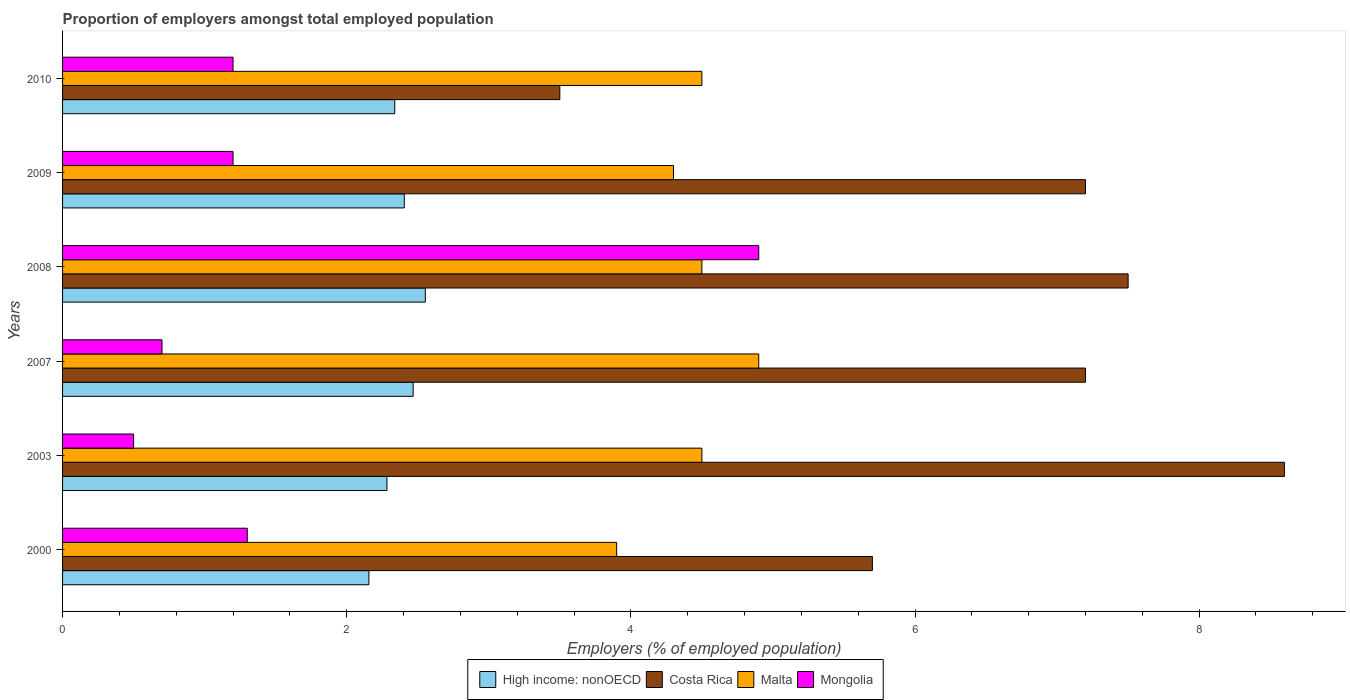How many bars are there on the 6th tick from the bottom?
Keep it short and to the point. 4. Across all years, what is the maximum proportion of employers in High income: nonOECD?
Give a very brief answer. 2.55. In which year was the proportion of employers in High income: nonOECD maximum?
Keep it short and to the point. 2008. In which year was the proportion of employers in High income: nonOECD minimum?
Your response must be concise. 2000. What is the total proportion of employers in High income: nonOECD in the graph?
Give a very brief answer. 14.2. What is the difference between the proportion of employers in Mongolia in 2010 and the proportion of employers in Malta in 2003?
Your response must be concise. -3.3. What is the average proportion of employers in Costa Rica per year?
Offer a very short reply. 6.62. In the year 2010, what is the difference between the proportion of employers in Mongolia and proportion of employers in Malta?
Provide a short and direct response. -3.3. In how many years, is the proportion of employers in High income: nonOECD greater than 5.2 %?
Provide a succinct answer. 0. What is the ratio of the proportion of employers in Costa Rica in 2003 to that in 2008?
Your answer should be compact. 1.15. Is the difference between the proportion of employers in Mongolia in 2003 and 2007 greater than the difference between the proportion of employers in Malta in 2003 and 2007?
Your response must be concise. Yes. What is the difference between the highest and the second highest proportion of employers in Costa Rica?
Provide a short and direct response. 1.1. What is the difference between the highest and the lowest proportion of employers in Malta?
Provide a short and direct response. 1. In how many years, is the proportion of employers in High income: nonOECD greater than the average proportion of employers in High income: nonOECD taken over all years?
Provide a succinct answer. 3. Is the sum of the proportion of employers in Costa Rica in 2000 and 2007 greater than the maximum proportion of employers in High income: nonOECD across all years?
Keep it short and to the point. Yes. Is it the case that in every year, the sum of the proportion of employers in Malta and proportion of employers in Costa Rica is greater than the sum of proportion of employers in High income: nonOECD and proportion of employers in Mongolia?
Offer a terse response. No. What does the 4th bar from the top in 2007 represents?
Provide a short and direct response. High income: nonOECD. What does the 2nd bar from the bottom in 2010 represents?
Offer a terse response. Costa Rica. How many legend labels are there?
Give a very brief answer. 4. What is the title of the graph?
Offer a very short reply. Proportion of employers amongst total employed population. What is the label or title of the X-axis?
Your response must be concise. Employers (% of employed population). What is the Employers (% of employed population) of High income: nonOECD in 2000?
Make the answer very short. 2.16. What is the Employers (% of employed population) in Costa Rica in 2000?
Your response must be concise. 5.7. What is the Employers (% of employed population) in Malta in 2000?
Ensure brevity in your answer.  3.9. What is the Employers (% of employed population) in Mongolia in 2000?
Offer a terse response. 1.3. What is the Employers (% of employed population) of High income: nonOECD in 2003?
Provide a succinct answer. 2.28. What is the Employers (% of employed population) in Costa Rica in 2003?
Make the answer very short. 8.6. What is the Employers (% of employed population) of High income: nonOECD in 2007?
Offer a very short reply. 2.47. What is the Employers (% of employed population) of Costa Rica in 2007?
Offer a terse response. 7.2. What is the Employers (% of employed population) in Malta in 2007?
Provide a short and direct response. 4.9. What is the Employers (% of employed population) in Mongolia in 2007?
Offer a very short reply. 0.7. What is the Employers (% of employed population) in High income: nonOECD in 2008?
Ensure brevity in your answer.  2.55. What is the Employers (% of employed population) of Malta in 2008?
Provide a succinct answer. 4.5. What is the Employers (% of employed population) of Mongolia in 2008?
Your response must be concise. 4.9. What is the Employers (% of employed population) in High income: nonOECD in 2009?
Offer a terse response. 2.41. What is the Employers (% of employed population) in Costa Rica in 2009?
Offer a terse response. 7.2. What is the Employers (% of employed population) of Malta in 2009?
Provide a short and direct response. 4.3. What is the Employers (% of employed population) in Mongolia in 2009?
Give a very brief answer. 1.2. What is the Employers (% of employed population) of High income: nonOECD in 2010?
Provide a succinct answer. 2.34. What is the Employers (% of employed population) in Costa Rica in 2010?
Offer a terse response. 3.5. What is the Employers (% of employed population) of Mongolia in 2010?
Ensure brevity in your answer.  1.2. Across all years, what is the maximum Employers (% of employed population) in High income: nonOECD?
Provide a succinct answer. 2.55. Across all years, what is the maximum Employers (% of employed population) of Costa Rica?
Provide a short and direct response. 8.6. Across all years, what is the maximum Employers (% of employed population) of Malta?
Ensure brevity in your answer.  4.9. Across all years, what is the maximum Employers (% of employed population) of Mongolia?
Your answer should be very brief. 4.9. Across all years, what is the minimum Employers (% of employed population) of High income: nonOECD?
Offer a very short reply. 2.16. Across all years, what is the minimum Employers (% of employed population) of Malta?
Give a very brief answer. 3.9. What is the total Employers (% of employed population) of High income: nonOECD in the graph?
Offer a terse response. 14.2. What is the total Employers (% of employed population) in Costa Rica in the graph?
Keep it short and to the point. 39.7. What is the total Employers (% of employed population) of Malta in the graph?
Give a very brief answer. 26.6. What is the total Employers (% of employed population) in Mongolia in the graph?
Keep it short and to the point. 9.8. What is the difference between the Employers (% of employed population) of High income: nonOECD in 2000 and that in 2003?
Make the answer very short. -0.13. What is the difference between the Employers (% of employed population) of High income: nonOECD in 2000 and that in 2007?
Provide a succinct answer. -0.31. What is the difference between the Employers (% of employed population) in Costa Rica in 2000 and that in 2007?
Offer a very short reply. -1.5. What is the difference between the Employers (% of employed population) in Mongolia in 2000 and that in 2007?
Provide a short and direct response. 0.6. What is the difference between the Employers (% of employed population) of High income: nonOECD in 2000 and that in 2008?
Provide a succinct answer. -0.4. What is the difference between the Employers (% of employed population) in Malta in 2000 and that in 2008?
Offer a very short reply. -0.6. What is the difference between the Employers (% of employed population) in High income: nonOECD in 2000 and that in 2009?
Keep it short and to the point. -0.25. What is the difference between the Employers (% of employed population) of Malta in 2000 and that in 2009?
Provide a short and direct response. -0.4. What is the difference between the Employers (% of employed population) in High income: nonOECD in 2000 and that in 2010?
Give a very brief answer. -0.18. What is the difference between the Employers (% of employed population) of Costa Rica in 2000 and that in 2010?
Offer a terse response. 2.2. What is the difference between the Employers (% of employed population) of Malta in 2000 and that in 2010?
Your answer should be compact. -0.6. What is the difference between the Employers (% of employed population) of High income: nonOECD in 2003 and that in 2007?
Your response must be concise. -0.18. What is the difference between the Employers (% of employed population) of Costa Rica in 2003 and that in 2007?
Ensure brevity in your answer.  1.4. What is the difference between the Employers (% of employed population) of Malta in 2003 and that in 2007?
Your answer should be compact. -0.4. What is the difference between the Employers (% of employed population) in High income: nonOECD in 2003 and that in 2008?
Give a very brief answer. -0.27. What is the difference between the Employers (% of employed population) in Costa Rica in 2003 and that in 2008?
Offer a terse response. 1.1. What is the difference between the Employers (% of employed population) of Malta in 2003 and that in 2008?
Your response must be concise. 0. What is the difference between the Employers (% of employed population) of High income: nonOECD in 2003 and that in 2009?
Offer a terse response. -0.12. What is the difference between the Employers (% of employed population) in High income: nonOECD in 2003 and that in 2010?
Your response must be concise. -0.06. What is the difference between the Employers (% of employed population) of Costa Rica in 2003 and that in 2010?
Give a very brief answer. 5.1. What is the difference between the Employers (% of employed population) of Mongolia in 2003 and that in 2010?
Provide a succinct answer. -0.7. What is the difference between the Employers (% of employed population) in High income: nonOECD in 2007 and that in 2008?
Make the answer very short. -0.09. What is the difference between the Employers (% of employed population) of Costa Rica in 2007 and that in 2008?
Your answer should be very brief. -0.3. What is the difference between the Employers (% of employed population) in High income: nonOECD in 2007 and that in 2009?
Your answer should be compact. 0.06. What is the difference between the Employers (% of employed population) in Malta in 2007 and that in 2009?
Offer a very short reply. 0.6. What is the difference between the Employers (% of employed population) of Mongolia in 2007 and that in 2009?
Your answer should be compact. -0.5. What is the difference between the Employers (% of employed population) in High income: nonOECD in 2007 and that in 2010?
Your response must be concise. 0.13. What is the difference between the Employers (% of employed population) of High income: nonOECD in 2008 and that in 2009?
Provide a short and direct response. 0.15. What is the difference between the Employers (% of employed population) of High income: nonOECD in 2008 and that in 2010?
Make the answer very short. 0.21. What is the difference between the Employers (% of employed population) in Malta in 2008 and that in 2010?
Provide a short and direct response. 0. What is the difference between the Employers (% of employed population) of Mongolia in 2008 and that in 2010?
Keep it short and to the point. 3.7. What is the difference between the Employers (% of employed population) in High income: nonOECD in 2009 and that in 2010?
Provide a short and direct response. 0.07. What is the difference between the Employers (% of employed population) of Malta in 2009 and that in 2010?
Make the answer very short. -0.2. What is the difference between the Employers (% of employed population) in High income: nonOECD in 2000 and the Employers (% of employed population) in Costa Rica in 2003?
Keep it short and to the point. -6.44. What is the difference between the Employers (% of employed population) in High income: nonOECD in 2000 and the Employers (% of employed population) in Malta in 2003?
Offer a terse response. -2.34. What is the difference between the Employers (% of employed population) in High income: nonOECD in 2000 and the Employers (% of employed population) in Mongolia in 2003?
Keep it short and to the point. 1.66. What is the difference between the Employers (% of employed population) of Malta in 2000 and the Employers (% of employed population) of Mongolia in 2003?
Your answer should be very brief. 3.4. What is the difference between the Employers (% of employed population) in High income: nonOECD in 2000 and the Employers (% of employed population) in Costa Rica in 2007?
Your answer should be very brief. -5.04. What is the difference between the Employers (% of employed population) of High income: nonOECD in 2000 and the Employers (% of employed population) of Malta in 2007?
Offer a terse response. -2.74. What is the difference between the Employers (% of employed population) of High income: nonOECD in 2000 and the Employers (% of employed population) of Mongolia in 2007?
Provide a succinct answer. 1.46. What is the difference between the Employers (% of employed population) of Costa Rica in 2000 and the Employers (% of employed population) of Mongolia in 2007?
Provide a short and direct response. 5. What is the difference between the Employers (% of employed population) of Malta in 2000 and the Employers (% of employed population) of Mongolia in 2007?
Give a very brief answer. 3.2. What is the difference between the Employers (% of employed population) of High income: nonOECD in 2000 and the Employers (% of employed population) of Costa Rica in 2008?
Make the answer very short. -5.34. What is the difference between the Employers (% of employed population) in High income: nonOECD in 2000 and the Employers (% of employed population) in Malta in 2008?
Keep it short and to the point. -2.34. What is the difference between the Employers (% of employed population) of High income: nonOECD in 2000 and the Employers (% of employed population) of Mongolia in 2008?
Ensure brevity in your answer.  -2.74. What is the difference between the Employers (% of employed population) of Costa Rica in 2000 and the Employers (% of employed population) of Malta in 2008?
Offer a very short reply. 1.2. What is the difference between the Employers (% of employed population) of Costa Rica in 2000 and the Employers (% of employed population) of Mongolia in 2008?
Keep it short and to the point. 0.8. What is the difference between the Employers (% of employed population) in Malta in 2000 and the Employers (% of employed population) in Mongolia in 2008?
Provide a succinct answer. -1. What is the difference between the Employers (% of employed population) of High income: nonOECD in 2000 and the Employers (% of employed population) of Costa Rica in 2009?
Your answer should be compact. -5.04. What is the difference between the Employers (% of employed population) in High income: nonOECD in 2000 and the Employers (% of employed population) in Malta in 2009?
Make the answer very short. -2.14. What is the difference between the Employers (% of employed population) of High income: nonOECD in 2000 and the Employers (% of employed population) of Mongolia in 2009?
Your answer should be very brief. 0.96. What is the difference between the Employers (% of employed population) in Costa Rica in 2000 and the Employers (% of employed population) in Mongolia in 2009?
Your answer should be very brief. 4.5. What is the difference between the Employers (% of employed population) of High income: nonOECD in 2000 and the Employers (% of employed population) of Costa Rica in 2010?
Your answer should be compact. -1.34. What is the difference between the Employers (% of employed population) in High income: nonOECD in 2000 and the Employers (% of employed population) in Malta in 2010?
Provide a succinct answer. -2.34. What is the difference between the Employers (% of employed population) in High income: nonOECD in 2000 and the Employers (% of employed population) in Mongolia in 2010?
Provide a short and direct response. 0.96. What is the difference between the Employers (% of employed population) of Costa Rica in 2000 and the Employers (% of employed population) of Mongolia in 2010?
Your answer should be very brief. 4.5. What is the difference between the Employers (% of employed population) of High income: nonOECD in 2003 and the Employers (% of employed population) of Costa Rica in 2007?
Your answer should be compact. -4.92. What is the difference between the Employers (% of employed population) of High income: nonOECD in 2003 and the Employers (% of employed population) of Malta in 2007?
Provide a succinct answer. -2.62. What is the difference between the Employers (% of employed population) of High income: nonOECD in 2003 and the Employers (% of employed population) of Mongolia in 2007?
Your answer should be compact. 1.58. What is the difference between the Employers (% of employed population) in Costa Rica in 2003 and the Employers (% of employed population) in Malta in 2007?
Give a very brief answer. 3.7. What is the difference between the Employers (% of employed population) in Costa Rica in 2003 and the Employers (% of employed population) in Mongolia in 2007?
Provide a short and direct response. 7.9. What is the difference between the Employers (% of employed population) of Malta in 2003 and the Employers (% of employed population) of Mongolia in 2007?
Offer a very short reply. 3.8. What is the difference between the Employers (% of employed population) of High income: nonOECD in 2003 and the Employers (% of employed population) of Costa Rica in 2008?
Provide a short and direct response. -5.22. What is the difference between the Employers (% of employed population) in High income: nonOECD in 2003 and the Employers (% of employed population) in Malta in 2008?
Your answer should be compact. -2.22. What is the difference between the Employers (% of employed population) of High income: nonOECD in 2003 and the Employers (% of employed population) of Mongolia in 2008?
Your response must be concise. -2.62. What is the difference between the Employers (% of employed population) of Costa Rica in 2003 and the Employers (% of employed population) of Malta in 2008?
Your answer should be compact. 4.1. What is the difference between the Employers (% of employed population) of Costa Rica in 2003 and the Employers (% of employed population) of Mongolia in 2008?
Keep it short and to the point. 3.7. What is the difference between the Employers (% of employed population) of High income: nonOECD in 2003 and the Employers (% of employed population) of Costa Rica in 2009?
Offer a very short reply. -4.92. What is the difference between the Employers (% of employed population) in High income: nonOECD in 2003 and the Employers (% of employed population) in Malta in 2009?
Your answer should be compact. -2.02. What is the difference between the Employers (% of employed population) in High income: nonOECD in 2003 and the Employers (% of employed population) in Mongolia in 2009?
Provide a short and direct response. 1.08. What is the difference between the Employers (% of employed population) in Costa Rica in 2003 and the Employers (% of employed population) in Malta in 2009?
Make the answer very short. 4.3. What is the difference between the Employers (% of employed population) in High income: nonOECD in 2003 and the Employers (% of employed population) in Costa Rica in 2010?
Give a very brief answer. -1.22. What is the difference between the Employers (% of employed population) in High income: nonOECD in 2003 and the Employers (% of employed population) in Malta in 2010?
Your answer should be compact. -2.22. What is the difference between the Employers (% of employed population) of High income: nonOECD in 2003 and the Employers (% of employed population) of Mongolia in 2010?
Make the answer very short. 1.08. What is the difference between the Employers (% of employed population) in Malta in 2003 and the Employers (% of employed population) in Mongolia in 2010?
Give a very brief answer. 3.3. What is the difference between the Employers (% of employed population) of High income: nonOECD in 2007 and the Employers (% of employed population) of Costa Rica in 2008?
Offer a terse response. -5.03. What is the difference between the Employers (% of employed population) of High income: nonOECD in 2007 and the Employers (% of employed population) of Malta in 2008?
Give a very brief answer. -2.03. What is the difference between the Employers (% of employed population) of High income: nonOECD in 2007 and the Employers (% of employed population) of Mongolia in 2008?
Provide a short and direct response. -2.43. What is the difference between the Employers (% of employed population) of Costa Rica in 2007 and the Employers (% of employed population) of Mongolia in 2008?
Offer a very short reply. 2.3. What is the difference between the Employers (% of employed population) of High income: nonOECD in 2007 and the Employers (% of employed population) of Costa Rica in 2009?
Keep it short and to the point. -4.73. What is the difference between the Employers (% of employed population) of High income: nonOECD in 2007 and the Employers (% of employed population) of Malta in 2009?
Your answer should be compact. -1.83. What is the difference between the Employers (% of employed population) in High income: nonOECD in 2007 and the Employers (% of employed population) in Mongolia in 2009?
Your response must be concise. 1.27. What is the difference between the Employers (% of employed population) in Costa Rica in 2007 and the Employers (% of employed population) in Malta in 2009?
Offer a terse response. 2.9. What is the difference between the Employers (% of employed population) in Costa Rica in 2007 and the Employers (% of employed population) in Mongolia in 2009?
Your answer should be compact. 6. What is the difference between the Employers (% of employed population) of Malta in 2007 and the Employers (% of employed population) of Mongolia in 2009?
Provide a short and direct response. 3.7. What is the difference between the Employers (% of employed population) in High income: nonOECD in 2007 and the Employers (% of employed population) in Costa Rica in 2010?
Offer a very short reply. -1.03. What is the difference between the Employers (% of employed population) in High income: nonOECD in 2007 and the Employers (% of employed population) in Malta in 2010?
Offer a terse response. -2.03. What is the difference between the Employers (% of employed population) in High income: nonOECD in 2007 and the Employers (% of employed population) in Mongolia in 2010?
Your answer should be very brief. 1.27. What is the difference between the Employers (% of employed population) in Costa Rica in 2007 and the Employers (% of employed population) in Malta in 2010?
Make the answer very short. 2.7. What is the difference between the Employers (% of employed population) of High income: nonOECD in 2008 and the Employers (% of employed population) of Costa Rica in 2009?
Give a very brief answer. -4.65. What is the difference between the Employers (% of employed population) in High income: nonOECD in 2008 and the Employers (% of employed population) in Malta in 2009?
Offer a terse response. -1.75. What is the difference between the Employers (% of employed population) in High income: nonOECD in 2008 and the Employers (% of employed population) in Mongolia in 2009?
Give a very brief answer. 1.35. What is the difference between the Employers (% of employed population) in Costa Rica in 2008 and the Employers (% of employed population) in Malta in 2009?
Your answer should be compact. 3.2. What is the difference between the Employers (% of employed population) in Malta in 2008 and the Employers (% of employed population) in Mongolia in 2009?
Provide a succinct answer. 3.3. What is the difference between the Employers (% of employed population) in High income: nonOECD in 2008 and the Employers (% of employed population) in Costa Rica in 2010?
Offer a terse response. -0.95. What is the difference between the Employers (% of employed population) of High income: nonOECD in 2008 and the Employers (% of employed population) of Malta in 2010?
Your answer should be very brief. -1.95. What is the difference between the Employers (% of employed population) of High income: nonOECD in 2008 and the Employers (% of employed population) of Mongolia in 2010?
Your answer should be compact. 1.35. What is the difference between the Employers (% of employed population) in Costa Rica in 2008 and the Employers (% of employed population) in Mongolia in 2010?
Provide a succinct answer. 6.3. What is the difference between the Employers (% of employed population) in High income: nonOECD in 2009 and the Employers (% of employed population) in Costa Rica in 2010?
Your answer should be compact. -1.09. What is the difference between the Employers (% of employed population) in High income: nonOECD in 2009 and the Employers (% of employed population) in Malta in 2010?
Ensure brevity in your answer.  -2.09. What is the difference between the Employers (% of employed population) of High income: nonOECD in 2009 and the Employers (% of employed population) of Mongolia in 2010?
Ensure brevity in your answer.  1.21. What is the difference between the Employers (% of employed population) in Costa Rica in 2009 and the Employers (% of employed population) in Malta in 2010?
Offer a terse response. 2.7. What is the difference between the Employers (% of employed population) of Costa Rica in 2009 and the Employers (% of employed population) of Mongolia in 2010?
Give a very brief answer. 6. What is the average Employers (% of employed population) in High income: nonOECD per year?
Your answer should be compact. 2.37. What is the average Employers (% of employed population) of Costa Rica per year?
Keep it short and to the point. 6.62. What is the average Employers (% of employed population) in Malta per year?
Ensure brevity in your answer.  4.43. What is the average Employers (% of employed population) in Mongolia per year?
Keep it short and to the point. 1.63. In the year 2000, what is the difference between the Employers (% of employed population) in High income: nonOECD and Employers (% of employed population) in Costa Rica?
Provide a succinct answer. -3.54. In the year 2000, what is the difference between the Employers (% of employed population) of High income: nonOECD and Employers (% of employed population) of Malta?
Provide a short and direct response. -1.74. In the year 2000, what is the difference between the Employers (% of employed population) of High income: nonOECD and Employers (% of employed population) of Mongolia?
Ensure brevity in your answer.  0.86. In the year 2000, what is the difference between the Employers (% of employed population) in Costa Rica and Employers (% of employed population) in Malta?
Provide a succinct answer. 1.8. In the year 2003, what is the difference between the Employers (% of employed population) of High income: nonOECD and Employers (% of employed population) of Costa Rica?
Provide a short and direct response. -6.32. In the year 2003, what is the difference between the Employers (% of employed population) of High income: nonOECD and Employers (% of employed population) of Malta?
Provide a short and direct response. -2.22. In the year 2003, what is the difference between the Employers (% of employed population) of High income: nonOECD and Employers (% of employed population) of Mongolia?
Give a very brief answer. 1.78. In the year 2003, what is the difference between the Employers (% of employed population) in Costa Rica and Employers (% of employed population) in Malta?
Give a very brief answer. 4.1. In the year 2003, what is the difference between the Employers (% of employed population) of Costa Rica and Employers (% of employed population) of Mongolia?
Give a very brief answer. 8.1. In the year 2003, what is the difference between the Employers (% of employed population) of Malta and Employers (% of employed population) of Mongolia?
Provide a short and direct response. 4. In the year 2007, what is the difference between the Employers (% of employed population) of High income: nonOECD and Employers (% of employed population) of Costa Rica?
Your answer should be very brief. -4.73. In the year 2007, what is the difference between the Employers (% of employed population) in High income: nonOECD and Employers (% of employed population) in Malta?
Make the answer very short. -2.43. In the year 2007, what is the difference between the Employers (% of employed population) of High income: nonOECD and Employers (% of employed population) of Mongolia?
Your answer should be very brief. 1.77. In the year 2007, what is the difference between the Employers (% of employed population) of Costa Rica and Employers (% of employed population) of Mongolia?
Keep it short and to the point. 6.5. In the year 2008, what is the difference between the Employers (% of employed population) in High income: nonOECD and Employers (% of employed population) in Costa Rica?
Your response must be concise. -4.95. In the year 2008, what is the difference between the Employers (% of employed population) of High income: nonOECD and Employers (% of employed population) of Malta?
Offer a very short reply. -1.95. In the year 2008, what is the difference between the Employers (% of employed population) in High income: nonOECD and Employers (% of employed population) in Mongolia?
Provide a succinct answer. -2.35. In the year 2008, what is the difference between the Employers (% of employed population) of Costa Rica and Employers (% of employed population) of Malta?
Your answer should be compact. 3. In the year 2008, what is the difference between the Employers (% of employed population) in Malta and Employers (% of employed population) in Mongolia?
Your response must be concise. -0.4. In the year 2009, what is the difference between the Employers (% of employed population) of High income: nonOECD and Employers (% of employed population) of Costa Rica?
Provide a succinct answer. -4.79. In the year 2009, what is the difference between the Employers (% of employed population) in High income: nonOECD and Employers (% of employed population) in Malta?
Your answer should be very brief. -1.89. In the year 2009, what is the difference between the Employers (% of employed population) of High income: nonOECD and Employers (% of employed population) of Mongolia?
Offer a very short reply. 1.21. In the year 2009, what is the difference between the Employers (% of employed population) of Costa Rica and Employers (% of employed population) of Malta?
Your response must be concise. 2.9. In the year 2009, what is the difference between the Employers (% of employed population) of Costa Rica and Employers (% of employed population) of Mongolia?
Offer a very short reply. 6. In the year 2009, what is the difference between the Employers (% of employed population) of Malta and Employers (% of employed population) of Mongolia?
Offer a very short reply. 3.1. In the year 2010, what is the difference between the Employers (% of employed population) of High income: nonOECD and Employers (% of employed population) of Costa Rica?
Your answer should be compact. -1.16. In the year 2010, what is the difference between the Employers (% of employed population) of High income: nonOECD and Employers (% of employed population) of Malta?
Make the answer very short. -2.16. In the year 2010, what is the difference between the Employers (% of employed population) of High income: nonOECD and Employers (% of employed population) of Mongolia?
Make the answer very short. 1.14. In the year 2010, what is the difference between the Employers (% of employed population) in Malta and Employers (% of employed population) in Mongolia?
Your response must be concise. 3.3. What is the ratio of the Employers (% of employed population) of Costa Rica in 2000 to that in 2003?
Make the answer very short. 0.66. What is the ratio of the Employers (% of employed population) in Malta in 2000 to that in 2003?
Ensure brevity in your answer.  0.87. What is the ratio of the Employers (% of employed population) of Mongolia in 2000 to that in 2003?
Make the answer very short. 2.6. What is the ratio of the Employers (% of employed population) in High income: nonOECD in 2000 to that in 2007?
Your answer should be compact. 0.87. What is the ratio of the Employers (% of employed population) of Costa Rica in 2000 to that in 2007?
Offer a very short reply. 0.79. What is the ratio of the Employers (% of employed population) of Malta in 2000 to that in 2007?
Make the answer very short. 0.8. What is the ratio of the Employers (% of employed population) in Mongolia in 2000 to that in 2007?
Your answer should be compact. 1.86. What is the ratio of the Employers (% of employed population) of High income: nonOECD in 2000 to that in 2008?
Ensure brevity in your answer.  0.84. What is the ratio of the Employers (% of employed population) of Costa Rica in 2000 to that in 2008?
Your answer should be very brief. 0.76. What is the ratio of the Employers (% of employed population) of Malta in 2000 to that in 2008?
Keep it short and to the point. 0.87. What is the ratio of the Employers (% of employed population) of Mongolia in 2000 to that in 2008?
Your answer should be compact. 0.27. What is the ratio of the Employers (% of employed population) of High income: nonOECD in 2000 to that in 2009?
Provide a succinct answer. 0.9. What is the ratio of the Employers (% of employed population) in Costa Rica in 2000 to that in 2009?
Your response must be concise. 0.79. What is the ratio of the Employers (% of employed population) in Malta in 2000 to that in 2009?
Make the answer very short. 0.91. What is the ratio of the Employers (% of employed population) of Mongolia in 2000 to that in 2009?
Give a very brief answer. 1.08. What is the ratio of the Employers (% of employed population) of High income: nonOECD in 2000 to that in 2010?
Your response must be concise. 0.92. What is the ratio of the Employers (% of employed population) in Costa Rica in 2000 to that in 2010?
Keep it short and to the point. 1.63. What is the ratio of the Employers (% of employed population) in Malta in 2000 to that in 2010?
Offer a very short reply. 0.87. What is the ratio of the Employers (% of employed population) of Mongolia in 2000 to that in 2010?
Offer a very short reply. 1.08. What is the ratio of the Employers (% of employed population) in High income: nonOECD in 2003 to that in 2007?
Offer a terse response. 0.93. What is the ratio of the Employers (% of employed population) in Costa Rica in 2003 to that in 2007?
Make the answer very short. 1.19. What is the ratio of the Employers (% of employed population) of Malta in 2003 to that in 2007?
Provide a short and direct response. 0.92. What is the ratio of the Employers (% of employed population) of High income: nonOECD in 2003 to that in 2008?
Provide a succinct answer. 0.89. What is the ratio of the Employers (% of employed population) in Costa Rica in 2003 to that in 2008?
Your answer should be very brief. 1.15. What is the ratio of the Employers (% of employed population) of Mongolia in 2003 to that in 2008?
Provide a short and direct response. 0.1. What is the ratio of the Employers (% of employed population) of High income: nonOECD in 2003 to that in 2009?
Your answer should be compact. 0.95. What is the ratio of the Employers (% of employed population) of Costa Rica in 2003 to that in 2009?
Provide a succinct answer. 1.19. What is the ratio of the Employers (% of employed population) of Malta in 2003 to that in 2009?
Your answer should be compact. 1.05. What is the ratio of the Employers (% of employed population) in Mongolia in 2003 to that in 2009?
Keep it short and to the point. 0.42. What is the ratio of the Employers (% of employed population) in High income: nonOECD in 2003 to that in 2010?
Your response must be concise. 0.98. What is the ratio of the Employers (% of employed population) of Costa Rica in 2003 to that in 2010?
Provide a short and direct response. 2.46. What is the ratio of the Employers (% of employed population) of Malta in 2003 to that in 2010?
Your response must be concise. 1. What is the ratio of the Employers (% of employed population) in Mongolia in 2003 to that in 2010?
Your answer should be compact. 0.42. What is the ratio of the Employers (% of employed population) of High income: nonOECD in 2007 to that in 2008?
Your answer should be compact. 0.97. What is the ratio of the Employers (% of employed population) in Malta in 2007 to that in 2008?
Your response must be concise. 1.09. What is the ratio of the Employers (% of employed population) of Mongolia in 2007 to that in 2008?
Ensure brevity in your answer.  0.14. What is the ratio of the Employers (% of employed population) in High income: nonOECD in 2007 to that in 2009?
Keep it short and to the point. 1.03. What is the ratio of the Employers (% of employed population) in Malta in 2007 to that in 2009?
Your answer should be compact. 1.14. What is the ratio of the Employers (% of employed population) of Mongolia in 2007 to that in 2009?
Provide a short and direct response. 0.58. What is the ratio of the Employers (% of employed population) in High income: nonOECD in 2007 to that in 2010?
Your answer should be very brief. 1.06. What is the ratio of the Employers (% of employed population) in Costa Rica in 2007 to that in 2010?
Ensure brevity in your answer.  2.06. What is the ratio of the Employers (% of employed population) of Malta in 2007 to that in 2010?
Make the answer very short. 1.09. What is the ratio of the Employers (% of employed population) of Mongolia in 2007 to that in 2010?
Provide a succinct answer. 0.58. What is the ratio of the Employers (% of employed population) of High income: nonOECD in 2008 to that in 2009?
Your answer should be compact. 1.06. What is the ratio of the Employers (% of employed population) of Costa Rica in 2008 to that in 2009?
Keep it short and to the point. 1.04. What is the ratio of the Employers (% of employed population) of Malta in 2008 to that in 2009?
Provide a succinct answer. 1.05. What is the ratio of the Employers (% of employed population) of Mongolia in 2008 to that in 2009?
Provide a short and direct response. 4.08. What is the ratio of the Employers (% of employed population) of High income: nonOECD in 2008 to that in 2010?
Your response must be concise. 1.09. What is the ratio of the Employers (% of employed population) of Costa Rica in 2008 to that in 2010?
Your answer should be very brief. 2.14. What is the ratio of the Employers (% of employed population) of Mongolia in 2008 to that in 2010?
Give a very brief answer. 4.08. What is the ratio of the Employers (% of employed population) of High income: nonOECD in 2009 to that in 2010?
Give a very brief answer. 1.03. What is the ratio of the Employers (% of employed population) of Costa Rica in 2009 to that in 2010?
Keep it short and to the point. 2.06. What is the ratio of the Employers (% of employed population) of Malta in 2009 to that in 2010?
Make the answer very short. 0.96. What is the ratio of the Employers (% of employed population) in Mongolia in 2009 to that in 2010?
Offer a very short reply. 1. What is the difference between the highest and the second highest Employers (% of employed population) in High income: nonOECD?
Provide a short and direct response. 0.09. What is the difference between the highest and the lowest Employers (% of employed population) in High income: nonOECD?
Provide a short and direct response. 0.4. What is the difference between the highest and the lowest Employers (% of employed population) in Costa Rica?
Keep it short and to the point. 5.1. What is the difference between the highest and the lowest Employers (% of employed population) in Malta?
Keep it short and to the point. 1. 